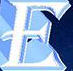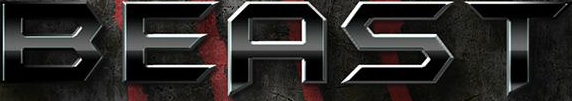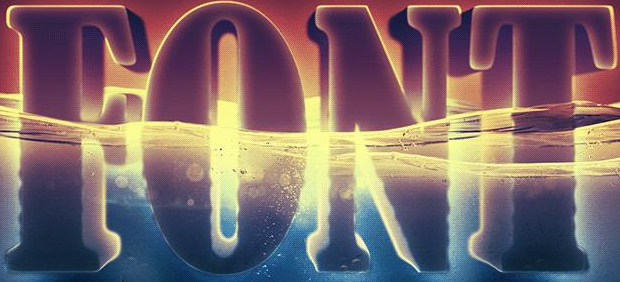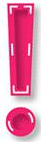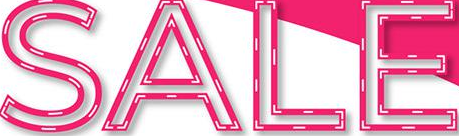What text is displayed in these images sequentially, separated by a semicolon? E; BEAST; FONT; !; SALE 